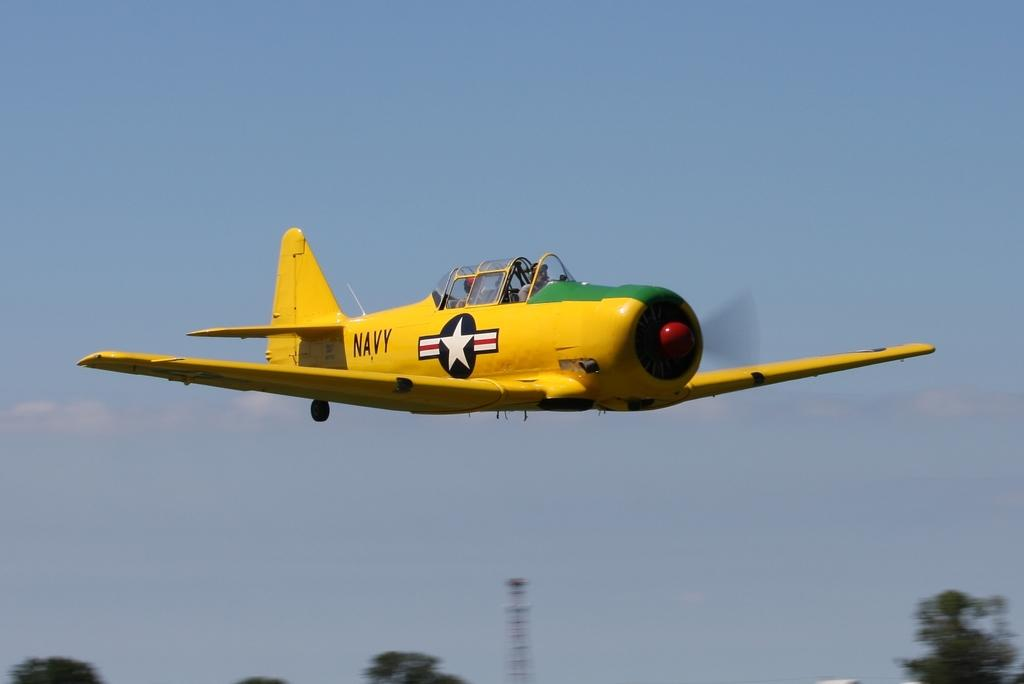<image>
Share a concise interpretation of the image provided. a plane that is yellow with the word Navy 